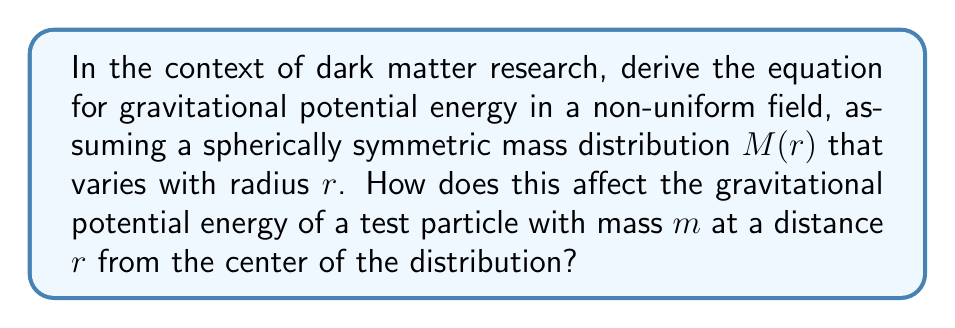Help me with this question. 1) In a non-uniform field, the gravitational force varies with position. For a spherically symmetric mass distribution, we can use Gauss's law for gravity:

   $$\vec{g}(r) = -\frac{GM(r)}{r^2}\hat{r}$$

   where $G$ is the gravitational constant and $M(r)$ is the mass enclosed within radius $r$.

2) The gravitational potential energy $U$ is related to the gravitational field $\vec{g}$ by:

   $$\vec{g} = -\nabla U$$

3) In spherical coordinates, for a radial field:

   $$\frac{dU}{dr} = -g(r) = \frac{GM(r)}{r^2}$$

4) To find $U(r)$, we integrate:

   $$U(r) = -\int_\infty^r \frac{GM(r')}{r'^2} dr'$$

5) This integral can't be evaluated further without knowing the specific form of $M(r)$. However, we can express the potential energy of a test particle with mass $m$ at radius $r$ as:

   $$U(r) = -mG\int_\infty^r \frac{M(r')}{r'^2} dr'$$

6) This formula differs from the uniform field case (where $M(r) = M$ constant) in that the mass function $M(r)$ remains inside the integral.

7) For dark matter research, this formulation allows for the exploration of various dark matter density profiles by specifying different functions for $M(r)$.
Answer: $$U(r) = -mG\int_\infty^r \frac{M(r')}{r'^2} dr'$$ 